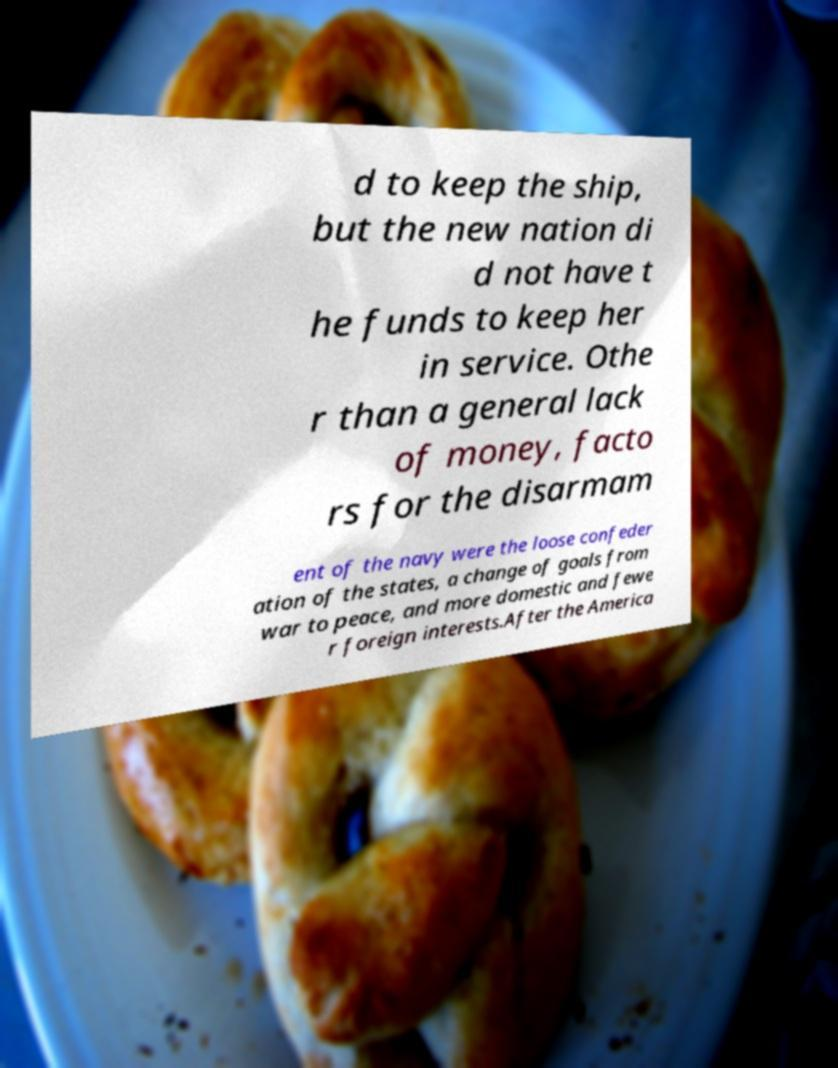Could you assist in decoding the text presented in this image and type it out clearly? d to keep the ship, but the new nation di d not have t he funds to keep her in service. Othe r than a general lack of money, facto rs for the disarmam ent of the navy were the loose confeder ation of the states, a change of goals from war to peace, and more domestic and fewe r foreign interests.After the America 